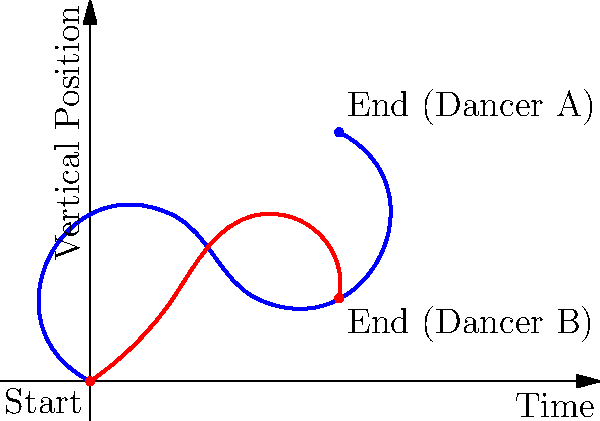Analyze the graph depicting the movement paths of two dancers. How does the visual representation of their trajectories reflect the differences in their choreography, and what insights can be drawn about the dynamics of their performance? 1. Identify the dancers:
   - Blue line represents Dancer A
   - Red line represents Dancer B

2. Analyze starting positions:
   - Both dancers start at the origin (0,0), indicating they begin at the same point on stage

3. Examine the trajectories:
   - Dancer A (blue) has a more varied path with higher peaks
   - Dancer B (red) follows a more consistent, wave-like pattern

4. Compare ending positions:
   - Dancer A ends at a higher vertical position (3,3)
   - Dancer B finishes at a lower point (3,1)

5. Interpret the choreography:
   - Dancer A's movements suggest more dramatic, expansive gestures with greater changes in elevation
   - Dancer B's path implies smoother, more fluid movements with less vertical variation

6. Analyze dynamics:
   - Dancer A's sharp changes in direction indicate more abrupt, possibly staccato movements
   - Dancer B's gentler curves suggest a more legato, flowing style

7. Consider the interplay between dancers:
   - The intersecting paths show moments where the dancers' movements align or contrast
   - These intersections could represent choreographic elements like mirroring or counterpoint

8. Reflect on the visual representation:
   - The line drawing effectively captures the essence of the dance without depicting actual bodies
   - It allows for a clear comparison of movement qualities and spatial relationships
Answer: The graph reveals contrasting choreographies: Dancer A performs expansive, dynamic movements with dramatic elevation changes, while Dancer B executes smoother, more consistent motions, highlighting the diverse kinetic and spatial elements of the dance composition. 